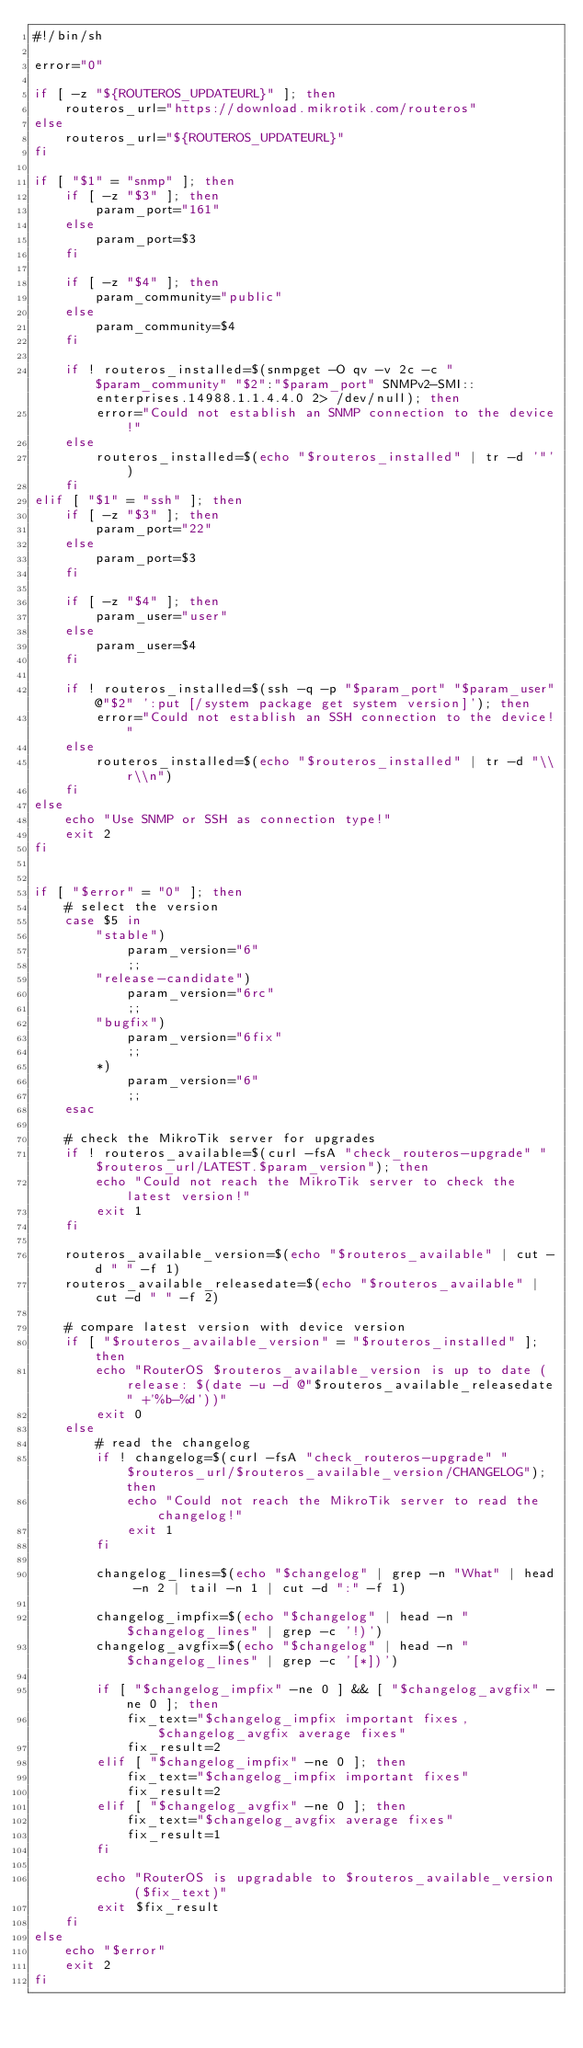Convert code to text. <code><loc_0><loc_0><loc_500><loc_500><_Bash_>#!/bin/sh

error="0"

if [ -z "${ROUTEROS_UPDATEURL}" ]; then
    routeros_url="https://download.mikrotik.com/routeros"
else
    routeros_url="${ROUTEROS_UPDATEURL}"
fi

if [ "$1" = "snmp" ]; then
    if [ -z "$3" ]; then
        param_port="161"
    else
        param_port=$3
    fi

    if [ -z "$4" ]; then
        param_community="public"
    else
        param_community=$4
    fi

    if ! routeros_installed=$(snmpget -O qv -v 2c -c "$param_community" "$2":"$param_port" SNMPv2-SMI::enterprises.14988.1.1.4.4.0 2> /dev/null); then
        error="Could not establish an SNMP connection to the device!"
    else
        routeros_installed=$(echo "$routeros_installed" | tr -d '"')
    fi
elif [ "$1" = "ssh" ]; then
    if [ -z "$3" ]; then
        param_port="22"
    else
        param_port=$3
    fi

    if [ -z "$4" ]; then
        param_user="user"
    else
        param_user=$4
    fi

    if ! routeros_installed=$(ssh -q -p "$param_port" "$param_user"@"$2" ':put [/system package get system version]'); then
        error="Could not establish an SSH connection to the device!"
    else
        routeros_installed=$(echo "$routeros_installed" | tr -d "\\r\\n")
    fi
else
    echo "Use SNMP or SSH as connection type!"
    exit 2
fi


if [ "$error" = "0" ]; then
    # select the version
    case $5 in
        "stable")
            param_version="6"
            ;;
        "release-candidate")
            param_version="6rc"
            ;;
        "bugfix")
            param_version="6fix"
            ;;
        *)
            param_version="6"
            ;;
    esac

    # check the MikroTik server for upgrades
    if ! routeros_available=$(curl -fsA "check_routeros-upgrade" "$routeros_url/LATEST.$param_version"); then
        echo "Could not reach the MikroTik server to check the latest version!"
        exit 1
    fi

    routeros_available_version=$(echo "$routeros_available" | cut -d " " -f 1)
    routeros_available_releasedate=$(echo "$routeros_available" | cut -d " " -f 2)

    # compare latest version with device version
    if [ "$routeros_available_version" = "$routeros_installed" ]; then
        echo "RouterOS $routeros_available_version is up to date (release: $(date -u -d @"$routeros_available_releasedate" +'%b-%d'))"
        exit 0
    else
        # read the changelog
        if ! changelog=$(curl -fsA "check_routeros-upgrade" "$routeros_url/$routeros_available_version/CHANGELOG"); then
            echo "Could not reach the MikroTik server to read the changelog!"
            exit 1
        fi

        changelog_lines=$(echo "$changelog" | grep -n "What" | head -n 2 | tail -n 1 | cut -d ":" -f 1)

        changelog_impfix=$(echo "$changelog" | head -n "$changelog_lines" | grep -c '!)')
        changelog_avgfix=$(echo "$changelog" | head -n "$changelog_lines" | grep -c '[*])')

        if [ "$changelog_impfix" -ne 0 ] && [ "$changelog_avgfix" -ne 0 ]; then
            fix_text="$changelog_impfix important fixes, $changelog_avgfix average fixes"
            fix_result=2
        elif [ "$changelog_impfix" -ne 0 ]; then
            fix_text="$changelog_impfix important fixes"
            fix_result=2
        elif [ "$changelog_avgfix" -ne 0 ]; then
            fix_text="$changelog_avgfix average fixes"
            fix_result=1
        fi

        echo "RouterOS is upgradable to $routeros_available_version ($fix_text)"
        exit $fix_result
    fi
else
    echo "$error"
    exit 2
fi
</code> 